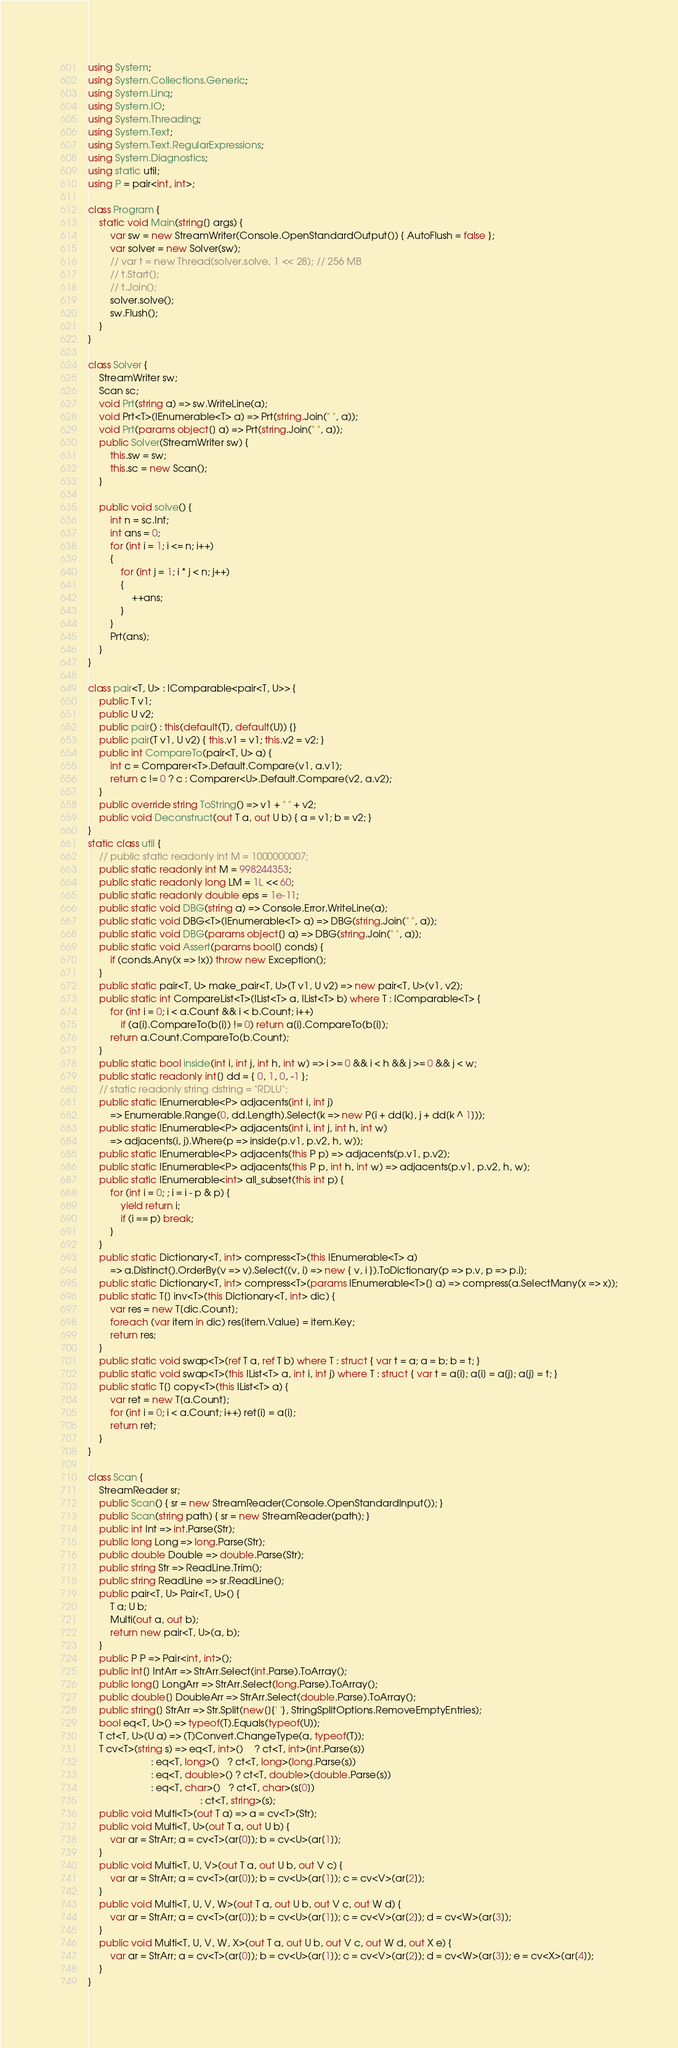Convert code to text. <code><loc_0><loc_0><loc_500><loc_500><_C#_>using System;
using System.Collections.Generic;
using System.Linq;
using System.IO;
using System.Threading;
using System.Text;
using System.Text.RegularExpressions;
using System.Diagnostics;
using static util;
using P = pair<int, int>;

class Program {
    static void Main(string[] args) {
        var sw = new StreamWriter(Console.OpenStandardOutput()) { AutoFlush = false };
        var solver = new Solver(sw);
        // var t = new Thread(solver.solve, 1 << 28); // 256 MB
        // t.Start();
        // t.Join();
        solver.solve();
        sw.Flush();
    }
}

class Solver {
    StreamWriter sw;
    Scan sc;
    void Prt(string a) => sw.WriteLine(a);
    void Prt<T>(IEnumerable<T> a) => Prt(string.Join(" ", a));
    void Prt(params object[] a) => Prt(string.Join(" ", a));
    public Solver(StreamWriter sw) {
        this.sw = sw;
        this.sc = new Scan();
    }

    public void solve() {
        int n = sc.Int;
        int ans = 0;
        for (int i = 1; i <= n; i++)
        {
            for (int j = 1; i * j < n; j++)
            {
                ++ans;
            }
        }
        Prt(ans);
    }
}

class pair<T, U> : IComparable<pair<T, U>> {
    public T v1;
    public U v2;
    public pair() : this(default(T), default(U)) {}
    public pair(T v1, U v2) { this.v1 = v1; this.v2 = v2; }
    public int CompareTo(pair<T, U> a) {
        int c = Comparer<T>.Default.Compare(v1, a.v1);
        return c != 0 ? c : Comparer<U>.Default.Compare(v2, a.v2);
    }
    public override string ToString() => v1 + " " + v2;
    public void Deconstruct(out T a, out U b) { a = v1; b = v2; }
}
static class util {
    // public static readonly int M = 1000000007;
    public static readonly int M = 998244353;
    public static readonly long LM = 1L << 60;
    public static readonly double eps = 1e-11;
    public static void DBG(string a) => Console.Error.WriteLine(a);
    public static void DBG<T>(IEnumerable<T> a) => DBG(string.Join(" ", a));
    public static void DBG(params object[] a) => DBG(string.Join(" ", a));
    public static void Assert(params bool[] conds) {
        if (conds.Any(x => !x)) throw new Exception();
    }
    public static pair<T, U> make_pair<T, U>(T v1, U v2) => new pair<T, U>(v1, v2);
    public static int CompareList<T>(IList<T> a, IList<T> b) where T : IComparable<T> {
        for (int i = 0; i < a.Count && i < b.Count; i++)
            if (a[i].CompareTo(b[i]) != 0) return a[i].CompareTo(b[i]);
        return a.Count.CompareTo(b.Count);
    }
    public static bool inside(int i, int j, int h, int w) => i >= 0 && i < h && j >= 0 && j < w;
    public static readonly int[] dd = { 0, 1, 0, -1 };
    // static readonly string dstring = "RDLU";
    public static IEnumerable<P> adjacents(int i, int j)
        => Enumerable.Range(0, dd.Length).Select(k => new P(i + dd[k], j + dd[k ^ 1]));
    public static IEnumerable<P> adjacents(int i, int j, int h, int w)
        => adjacents(i, j).Where(p => inside(p.v1, p.v2, h, w));
    public static IEnumerable<P> adjacents(this P p) => adjacents(p.v1, p.v2);
    public static IEnumerable<P> adjacents(this P p, int h, int w) => adjacents(p.v1, p.v2, h, w);
    public static IEnumerable<int> all_subset(this int p) {
        for (int i = 0; ; i = i - p & p) {
            yield return i;
            if (i == p) break;
        }
    }
    public static Dictionary<T, int> compress<T>(this IEnumerable<T> a)
        => a.Distinct().OrderBy(v => v).Select((v, i) => new { v, i }).ToDictionary(p => p.v, p => p.i);
    public static Dictionary<T, int> compress<T>(params IEnumerable<T>[] a) => compress(a.SelectMany(x => x));
    public static T[] inv<T>(this Dictionary<T, int> dic) {
        var res = new T[dic.Count];
        foreach (var item in dic) res[item.Value] = item.Key;
        return res;
    }
    public static void swap<T>(ref T a, ref T b) where T : struct { var t = a; a = b; b = t; }
    public static void swap<T>(this IList<T> a, int i, int j) where T : struct { var t = a[i]; a[i] = a[j]; a[j] = t; }
    public static T[] copy<T>(this IList<T> a) {
        var ret = new T[a.Count];
        for (int i = 0; i < a.Count; i++) ret[i] = a[i];
        return ret;
    }
}

class Scan {
    StreamReader sr;
    public Scan() { sr = new StreamReader(Console.OpenStandardInput()); }
    public Scan(string path) { sr = new StreamReader(path); }
    public int Int => int.Parse(Str);
    public long Long => long.Parse(Str);
    public double Double => double.Parse(Str);
    public string Str => ReadLine.Trim();
    public string ReadLine => sr.ReadLine();
    public pair<T, U> Pair<T, U>() {
        T a; U b;
        Multi(out a, out b);
        return new pair<T, U>(a, b);
    }
    public P P => Pair<int, int>();
    public int[] IntArr => StrArr.Select(int.Parse).ToArray();
    public long[] LongArr => StrArr.Select(long.Parse).ToArray();
    public double[] DoubleArr => StrArr.Select(double.Parse).ToArray();
    public string[] StrArr => Str.Split(new[]{' '}, StringSplitOptions.RemoveEmptyEntries);
    bool eq<T, U>() => typeof(T).Equals(typeof(U));
    T ct<T, U>(U a) => (T)Convert.ChangeType(a, typeof(T));
    T cv<T>(string s) => eq<T, int>()    ? ct<T, int>(int.Parse(s))
                       : eq<T, long>()   ? ct<T, long>(long.Parse(s))
                       : eq<T, double>() ? ct<T, double>(double.Parse(s))
                       : eq<T, char>()   ? ct<T, char>(s[0])
                                         : ct<T, string>(s);
    public void Multi<T>(out T a) => a = cv<T>(Str);
    public void Multi<T, U>(out T a, out U b) {
        var ar = StrArr; a = cv<T>(ar[0]); b = cv<U>(ar[1]);
    }
    public void Multi<T, U, V>(out T a, out U b, out V c) {
        var ar = StrArr; a = cv<T>(ar[0]); b = cv<U>(ar[1]); c = cv<V>(ar[2]);
    }
    public void Multi<T, U, V, W>(out T a, out U b, out V c, out W d) {
        var ar = StrArr; a = cv<T>(ar[0]); b = cv<U>(ar[1]); c = cv<V>(ar[2]); d = cv<W>(ar[3]);
    }
    public void Multi<T, U, V, W, X>(out T a, out U b, out V c, out W d, out X e) {
        var ar = StrArr; a = cv<T>(ar[0]); b = cv<U>(ar[1]); c = cv<V>(ar[2]); d = cv<W>(ar[3]); e = cv<X>(ar[4]);
    }
}
</code> 